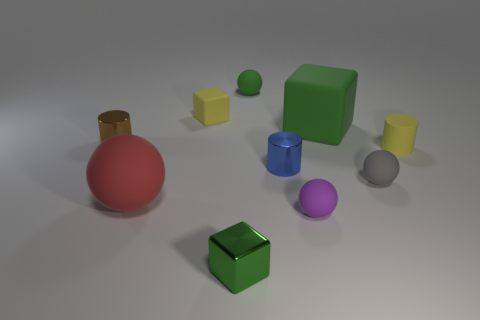There is a green matte thing on the right side of the small matte thing behind the tiny yellow thing behind the brown cylinder; what size is it?
Give a very brief answer. Large. What number of matte balls are the same size as the blue object?
Your answer should be compact. 3. How many things are either red matte objects or small metal cylinders on the right side of the small brown metallic object?
Your response must be concise. 2. What is the shape of the small purple thing?
Your answer should be compact. Sphere. Does the big block have the same color as the tiny metallic cube?
Offer a terse response. Yes. What color is the block that is the same size as the red rubber thing?
Your answer should be compact. Green. How many yellow objects are small rubber balls or rubber things?
Provide a succinct answer. 2. Is the number of rubber objects greater than the number of brown shiny things?
Provide a succinct answer. Yes. There is a cylinder that is on the right side of the tiny purple thing; is it the same size as the green block behind the tiny brown shiny cylinder?
Make the answer very short. No. What color is the matte thing that is in front of the large red rubber ball that is in front of the tiny object right of the small gray sphere?
Provide a succinct answer. Purple. 